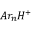<formula> <loc_0><loc_0><loc_500><loc_500>A r _ { n } H ^ { + }</formula> 